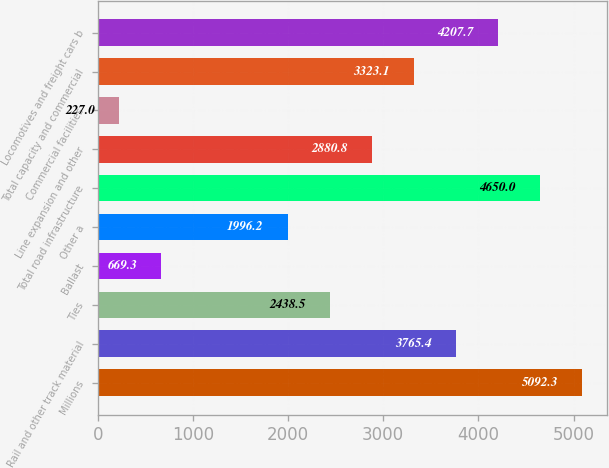<chart> <loc_0><loc_0><loc_500><loc_500><bar_chart><fcel>Millions<fcel>Rail and other track material<fcel>Ties<fcel>Ballast<fcel>Other a<fcel>Total road infrastructure<fcel>Line expansion and other<fcel>Commercial facilities<fcel>Total capacity and commercial<fcel>Locomotives and freight cars b<nl><fcel>5092.3<fcel>3765.4<fcel>2438.5<fcel>669.3<fcel>1996.2<fcel>4650<fcel>2880.8<fcel>227<fcel>3323.1<fcel>4207.7<nl></chart> 